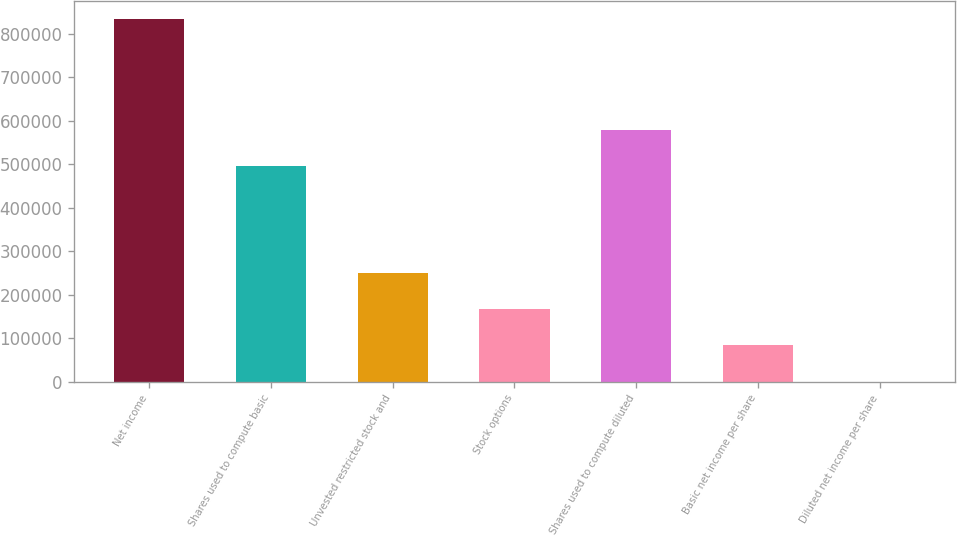Convert chart. <chart><loc_0><loc_0><loc_500><loc_500><bar_chart><fcel>Net income<fcel>Shares used to compute basic<fcel>Unvested restricted stock and<fcel>Stock options<fcel>Shares used to compute diluted<fcel>Basic net income per share<fcel>Diluted net income per share<nl><fcel>832775<fcel>494731<fcel>249834<fcel>166556<fcel>578008<fcel>83279<fcel>1.66<nl></chart> 